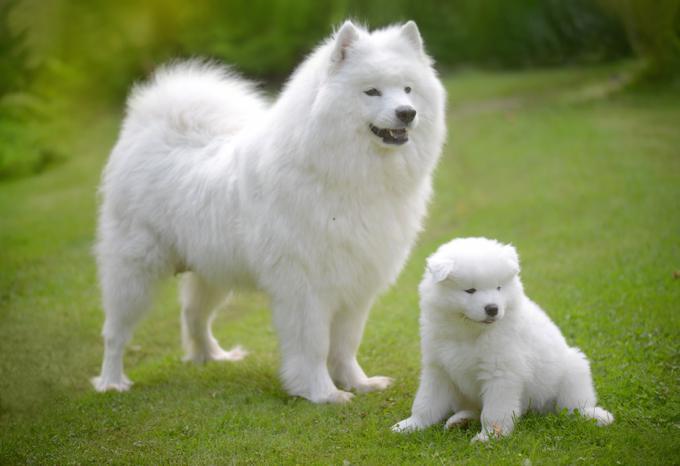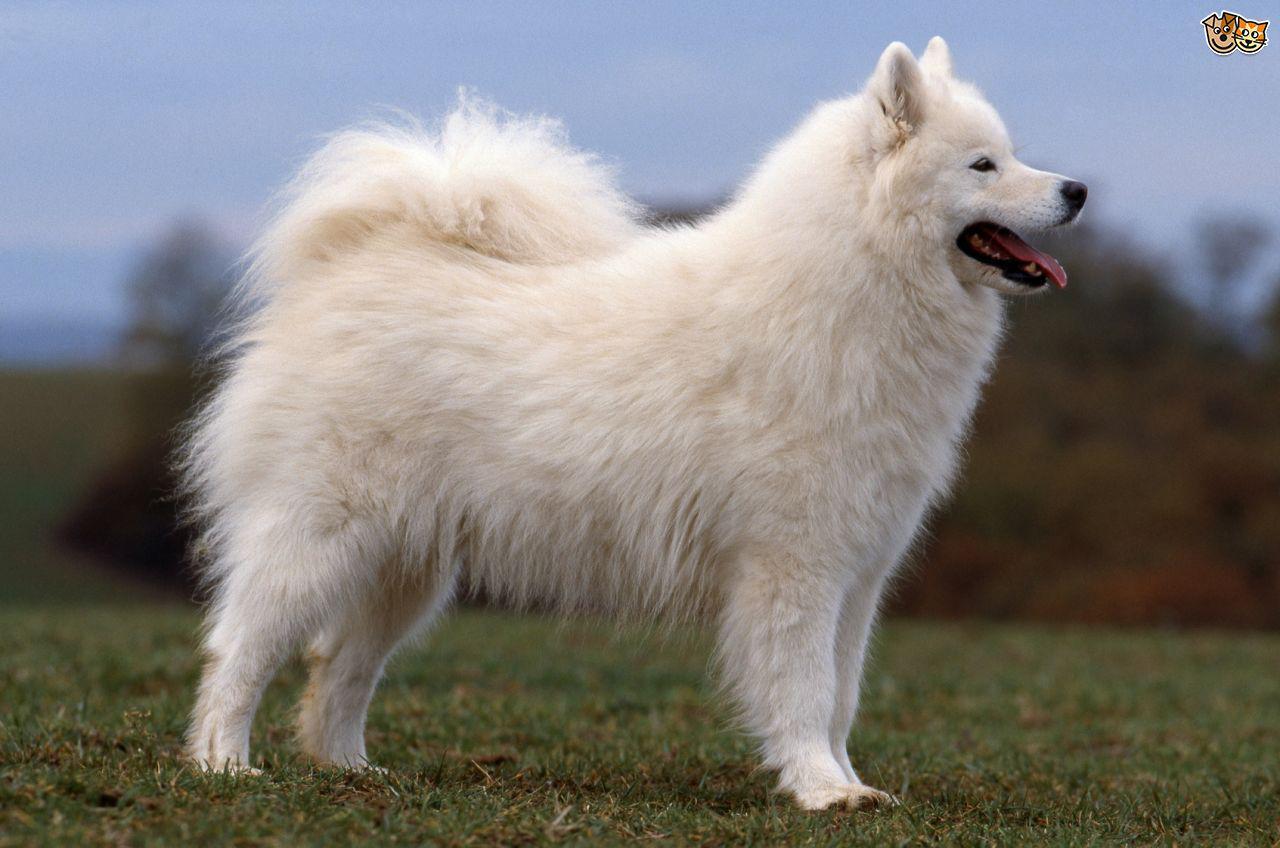The first image is the image on the left, the second image is the image on the right. Evaluate the accuracy of this statement regarding the images: "One dog is facing the right and one dog is facing the left.". Is it true? Answer yes or no. No. 